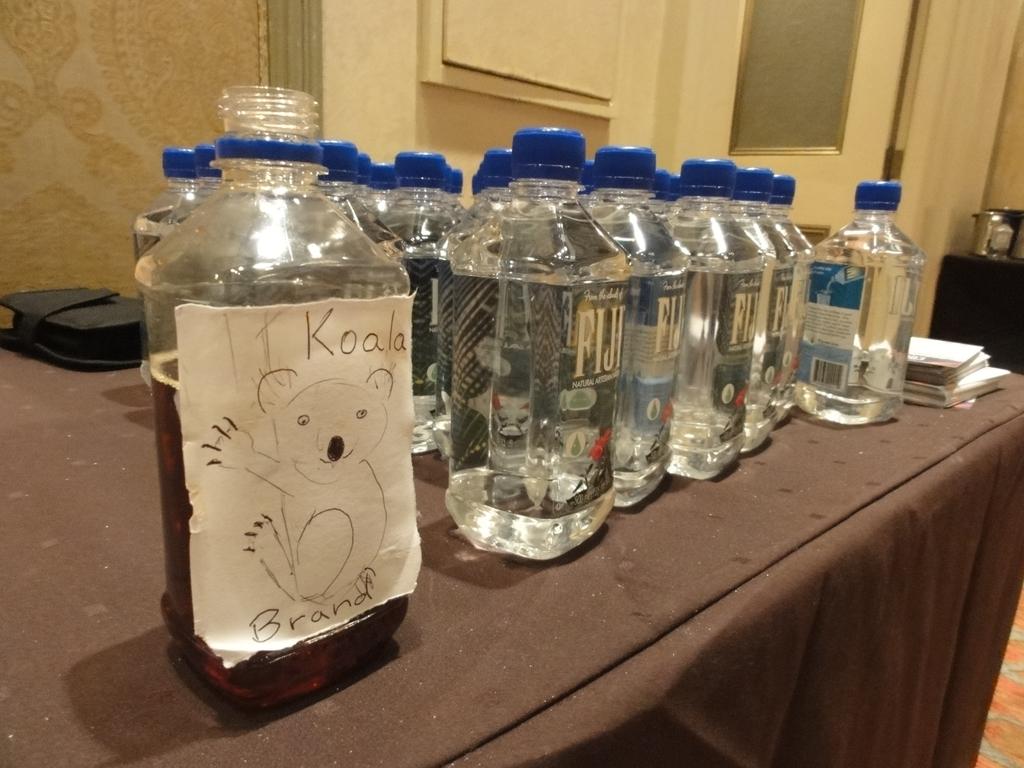What brand of water is shown?
Provide a short and direct response. Fiji. 